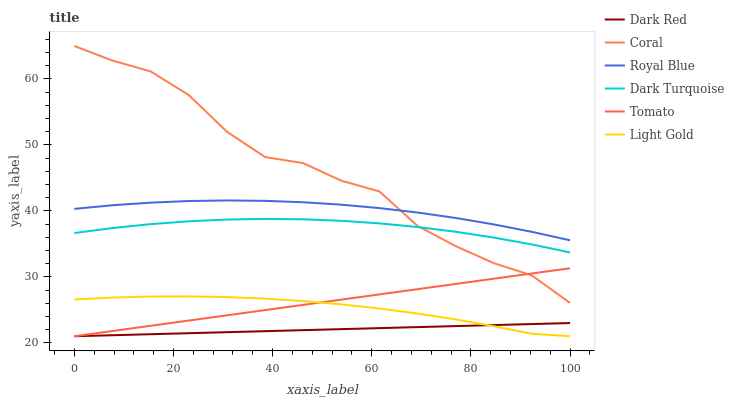Does Dark Red have the minimum area under the curve?
Answer yes or no. Yes. Does Coral have the maximum area under the curve?
Answer yes or no. Yes. Does Coral have the minimum area under the curve?
Answer yes or no. No. Does Dark Red have the maximum area under the curve?
Answer yes or no. No. Is Tomato the smoothest?
Answer yes or no. Yes. Is Coral the roughest?
Answer yes or no. Yes. Is Dark Red the smoothest?
Answer yes or no. No. Is Dark Red the roughest?
Answer yes or no. No. Does Tomato have the lowest value?
Answer yes or no. Yes. Does Coral have the lowest value?
Answer yes or no. No. Does Coral have the highest value?
Answer yes or no. Yes. Does Dark Red have the highest value?
Answer yes or no. No. Is Tomato less than Royal Blue?
Answer yes or no. Yes. Is Royal Blue greater than Tomato?
Answer yes or no. Yes. Does Light Gold intersect Tomato?
Answer yes or no. Yes. Is Light Gold less than Tomato?
Answer yes or no. No. Is Light Gold greater than Tomato?
Answer yes or no. No. Does Tomato intersect Royal Blue?
Answer yes or no. No. 